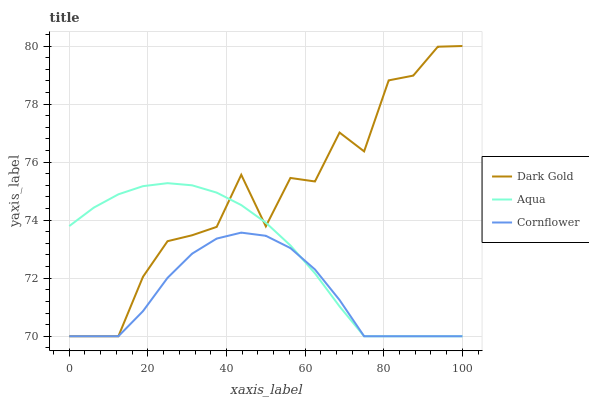Does Cornflower have the minimum area under the curve?
Answer yes or no. Yes. Does Dark Gold have the maximum area under the curve?
Answer yes or no. Yes. Does Aqua have the minimum area under the curve?
Answer yes or no. No. Does Aqua have the maximum area under the curve?
Answer yes or no. No. Is Aqua the smoothest?
Answer yes or no. Yes. Is Dark Gold the roughest?
Answer yes or no. Yes. Is Dark Gold the smoothest?
Answer yes or no. No. Is Aqua the roughest?
Answer yes or no. No. Does Cornflower have the lowest value?
Answer yes or no. Yes. Does Dark Gold have the highest value?
Answer yes or no. Yes. Does Aqua have the highest value?
Answer yes or no. No. Does Dark Gold intersect Cornflower?
Answer yes or no. Yes. Is Dark Gold less than Cornflower?
Answer yes or no. No. Is Dark Gold greater than Cornflower?
Answer yes or no. No. 